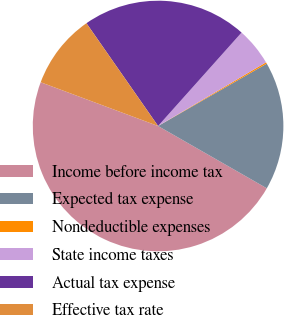Convert chart to OTSL. <chart><loc_0><loc_0><loc_500><loc_500><pie_chart><fcel>Income before income tax<fcel>Expected tax expense<fcel>Nondeductible expenses<fcel>State income taxes<fcel>Actual tax expense<fcel>Effective tax rate<nl><fcel>47.39%<fcel>16.57%<fcel>0.19%<fcel>4.91%<fcel>21.29%<fcel>9.63%<nl></chart> 